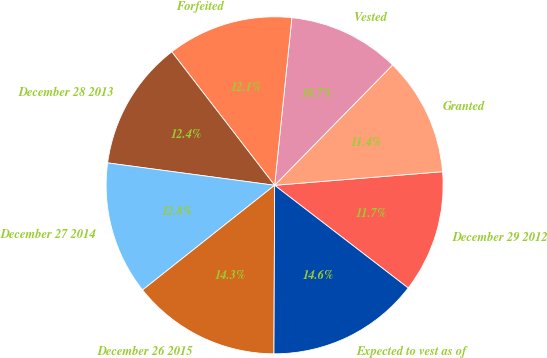Convert chart. <chart><loc_0><loc_0><loc_500><loc_500><pie_chart><fcel>December 29 2012<fcel>Granted<fcel>Vested<fcel>Forfeited<fcel>December 28 2013<fcel>December 27 2014<fcel>December 26 2015<fcel>Expected to vest as of<nl><fcel>11.72%<fcel>11.37%<fcel>10.71%<fcel>12.08%<fcel>12.43%<fcel>12.79%<fcel>14.27%<fcel>14.63%<nl></chart> 